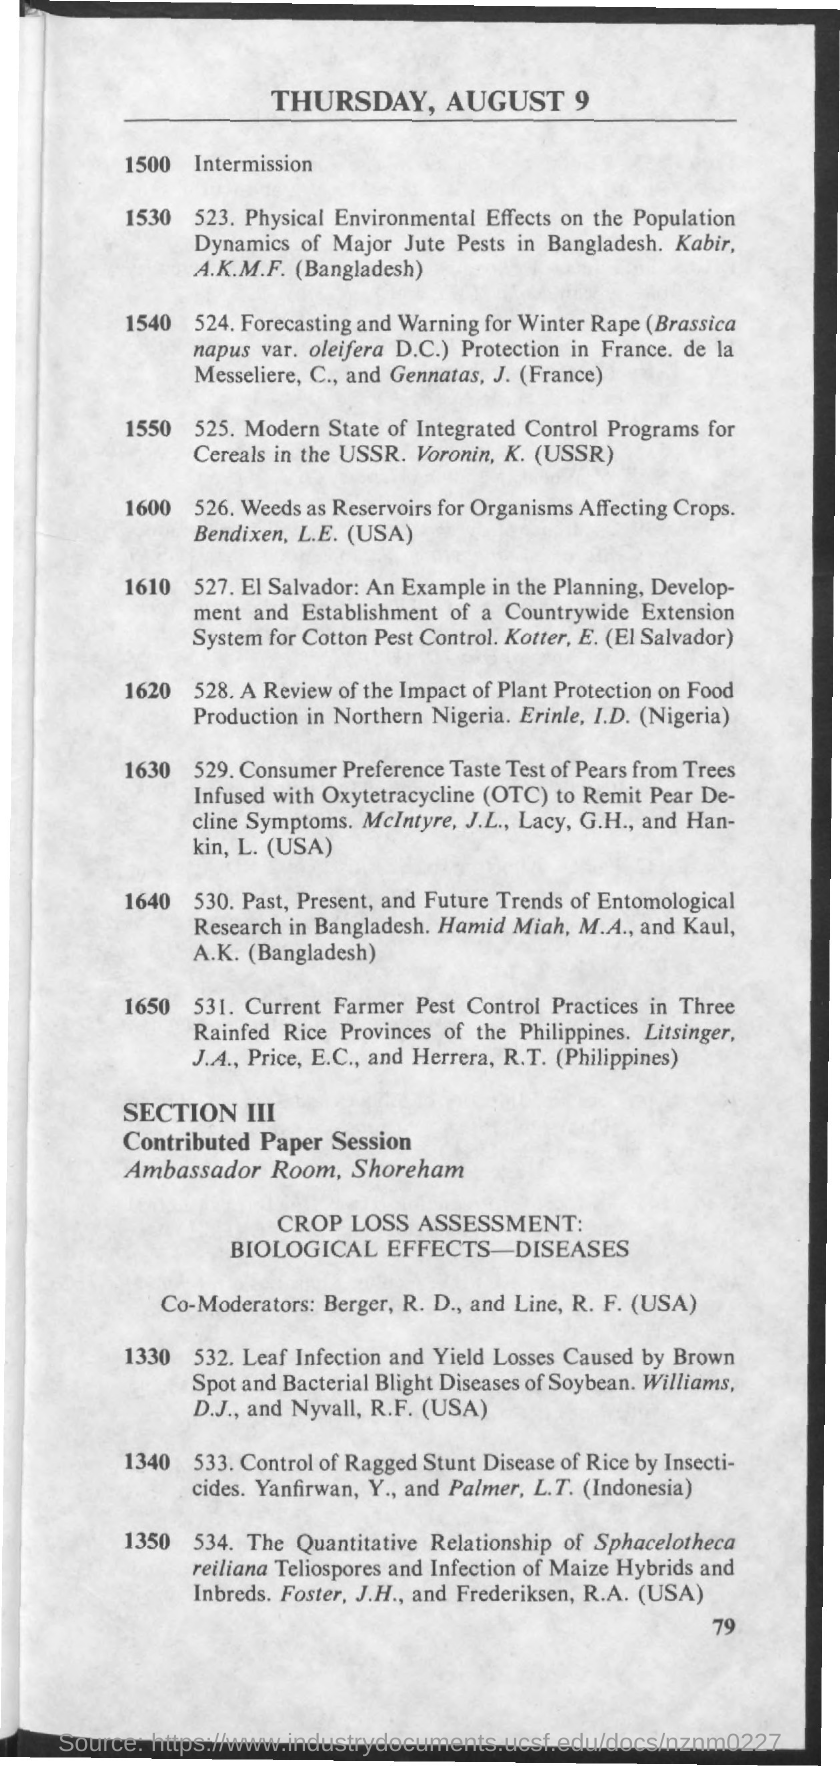Specify some key components in this picture. The document at the top mentions that the date is Thursday, August 9. The page number is 79. The co-moderators are Berger and Line, both of whom are R. D. and R. F. Line, respectively. 